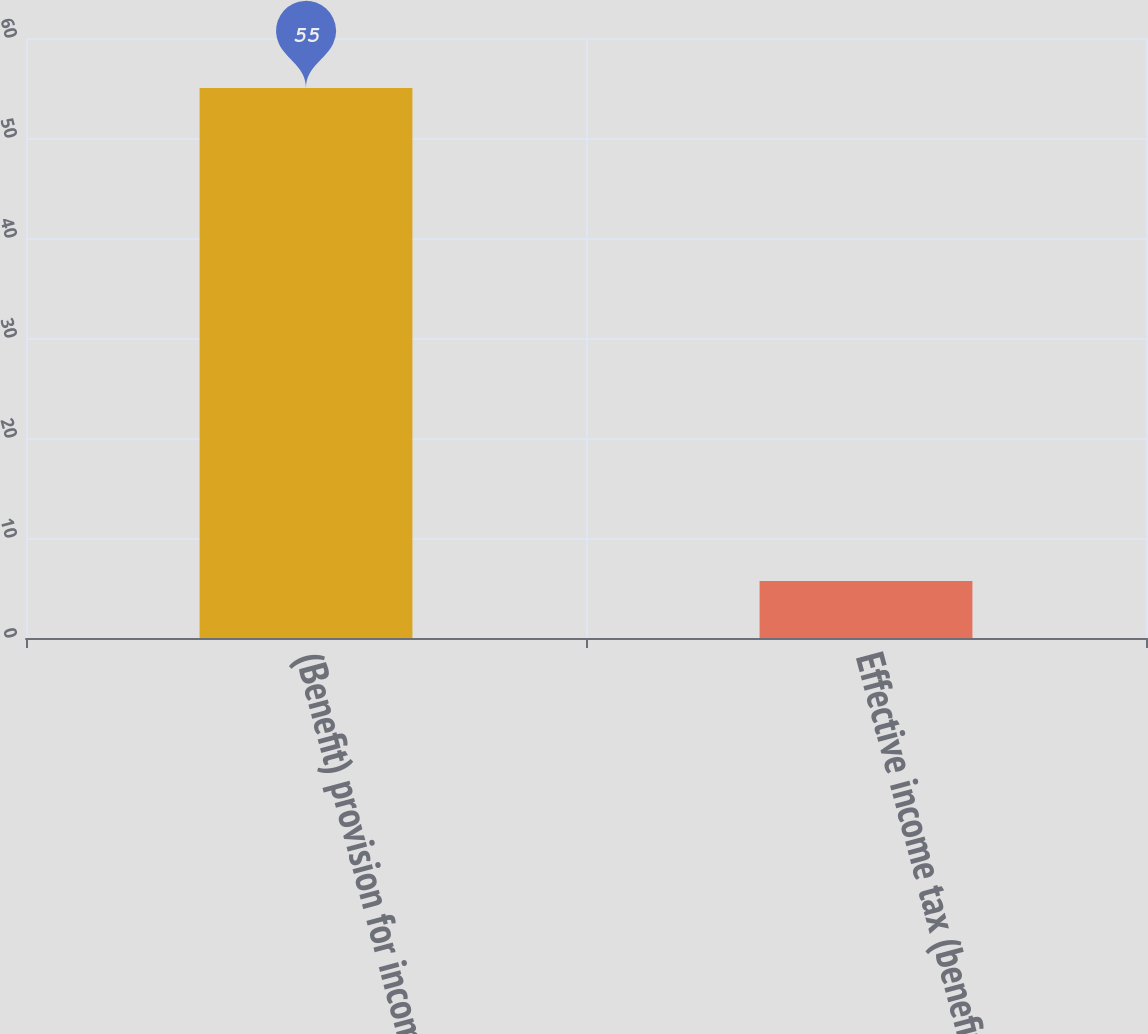Convert chart to OTSL. <chart><loc_0><loc_0><loc_500><loc_500><bar_chart><fcel>(Benefit) provision for income<fcel>Effective income tax (benefit)<nl><fcel>55<fcel>5.7<nl></chart> 